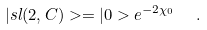<formula> <loc_0><loc_0><loc_500><loc_500>| s l ( 2 , C ) > = | 0 > e ^ { - 2 \chi _ { 0 } } \ \ .</formula> 